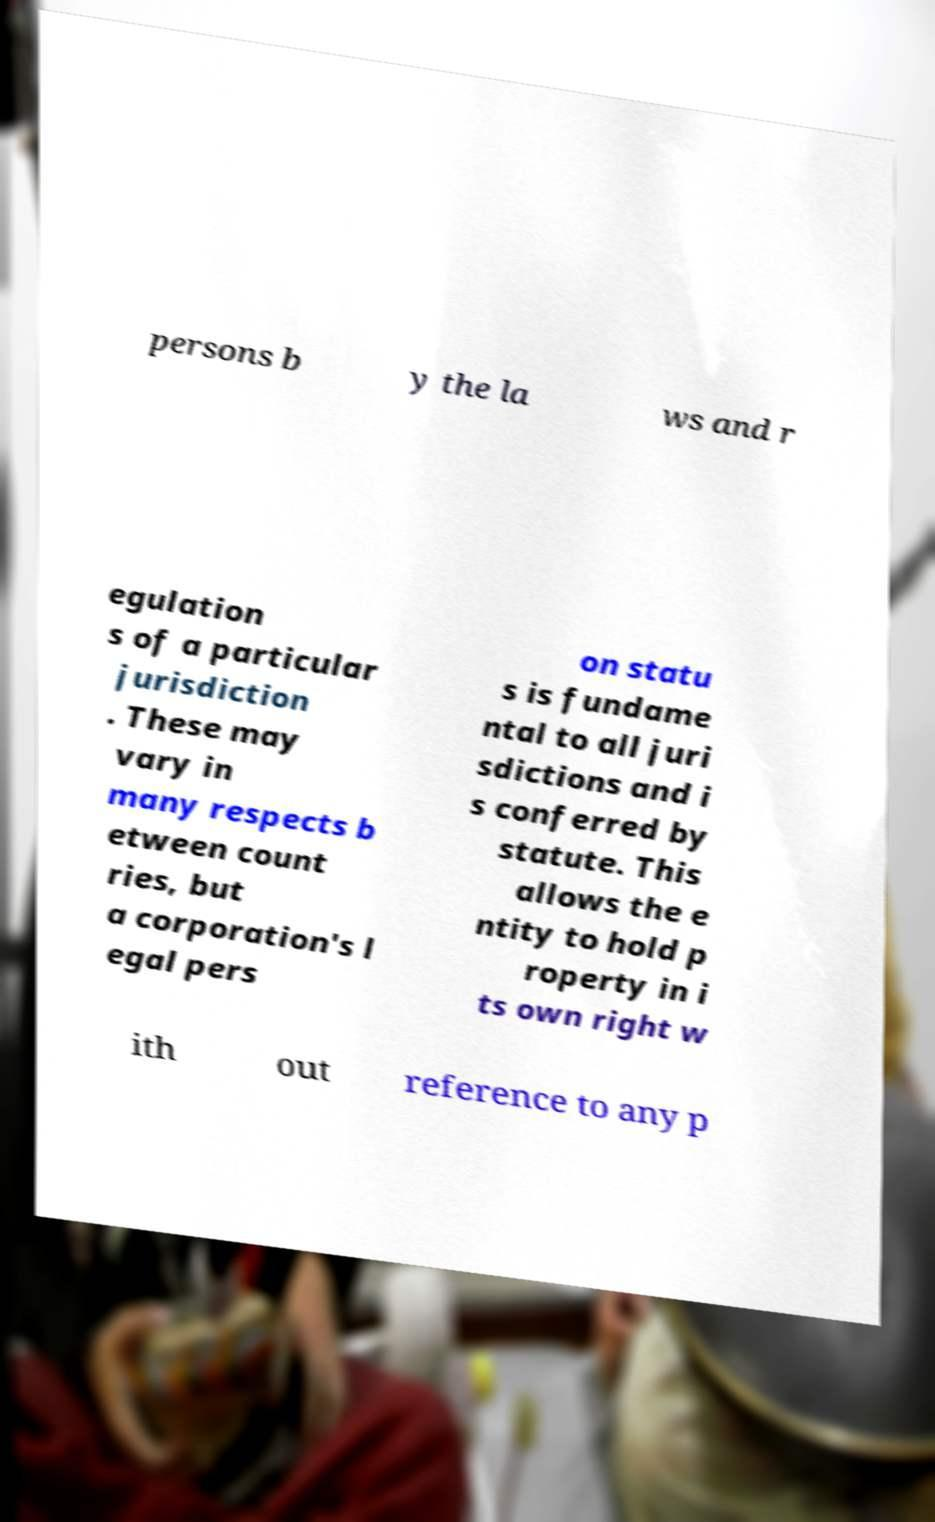Could you assist in decoding the text presented in this image and type it out clearly? persons b y the la ws and r egulation s of a particular jurisdiction . These may vary in many respects b etween count ries, but a corporation's l egal pers on statu s is fundame ntal to all juri sdictions and i s conferred by statute. This allows the e ntity to hold p roperty in i ts own right w ith out reference to any p 